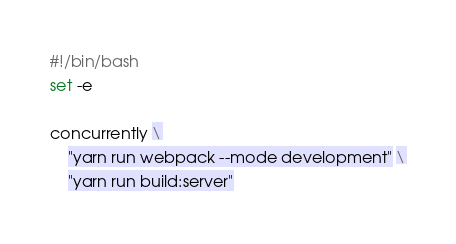<code> <loc_0><loc_0><loc_500><loc_500><_Bash_>#!/bin/bash
set -e

concurrently \
    "yarn run webpack --mode development" \
    "yarn run build:server"
</code> 